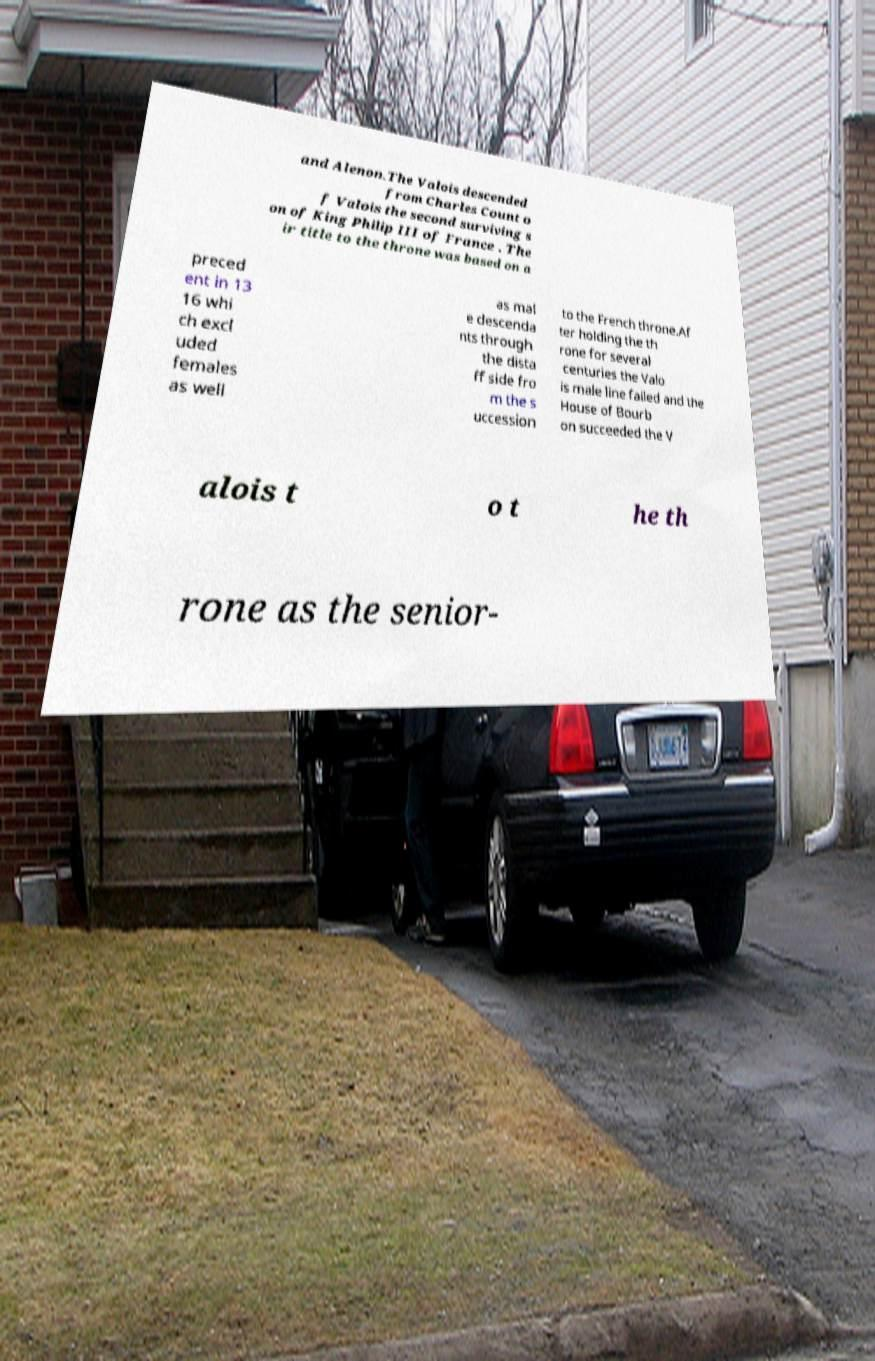Can you accurately transcribe the text from the provided image for me? and Alenon.The Valois descended from Charles Count o f Valois the second surviving s on of King Philip III of France . The ir title to the throne was based on a preced ent in 13 16 whi ch excl uded females as well as mal e descenda nts through the dista ff side fro m the s uccession to the French throne.Af ter holding the th rone for several centuries the Valo is male line failed and the House of Bourb on succeeded the V alois t o t he th rone as the senior- 